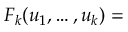Convert formula to latex. <formula><loc_0><loc_0><loc_500><loc_500>F _ { k } ( u _ { 1 } , \dots , u _ { k } ) =</formula> 